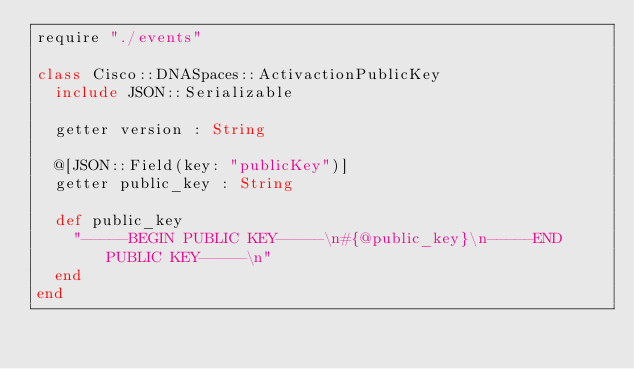<code> <loc_0><loc_0><loc_500><loc_500><_Crystal_>require "./events"

class Cisco::DNASpaces::ActivactionPublicKey
  include JSON::Serializable

  getter version : String

  @[JSON::Field(key: "publicKey")]
  getter public_key : String

  def public_key
    "-----BEGIN PUBLIC KEY-----\n#{@public_key}\n-----END PUBLIC KEY-----\n"
  end
end
</code> 